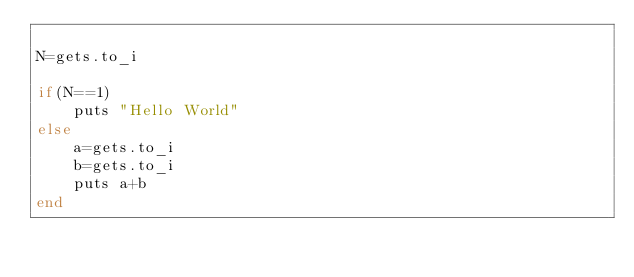Convert code to text. <code><loc_0><loc_0><loc_500><loc_500><_Ruby_>
N=gets.to_i

if(N==1)
    puts "Hello World"
else
    a=gets.to_i
    b=gets.to_i
    puts a+b
end</code> 